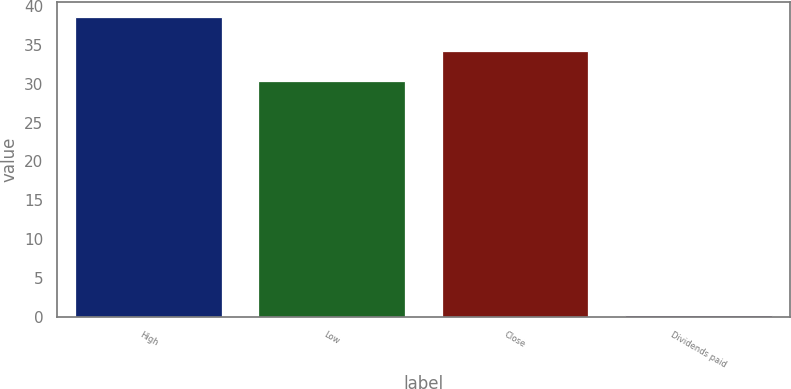Convert chart to OTSL. <chart><loc_0><loc_0><loc_500><loc_500><bar_chart><fcel>High<fcel>Low<fcel>Close<fcel>Dividends paid<nl><fcel>38.62<fcel>30.38<fcel>34.22<fcel>0.2<nl></chart> 